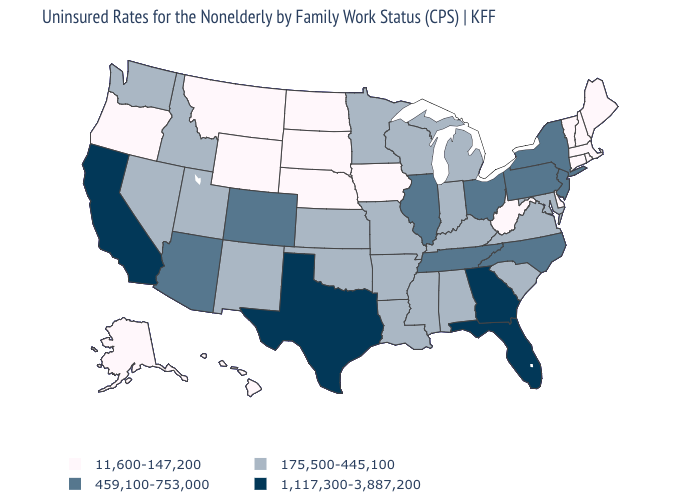What is the value of Tennessee?
Give a very brief answer. 459,100-753,000. Name the states that have a value in the range 1,117,300-3,887,200?
Short answer required. California, Florida, Georgia, Texas. Does Ohio have a lower value than Texas?
Keep it brief. Yes. Name the states that have a value in the range 11,600-147,200?
Give a very brief answer. Alaska, Connecticut, Delaware, Hawaii, Iowa, Maine, Massachusetts, Montana, Nebraska, New Hampshire, North Dakota, Oregon, Rhode Island, South Dakota, Vermont, West Virginia, Wyoming. What is the value of California?
Write a very short answer. 1,117,300-3,887,200. Does South Dakota have the highest value in the USA?
Give a very brief answer. No. Does Utah have a lower value than Minnesota?
Short answer required. No. Which states have the lowest value in the USA?
Answer briefly. Alaska, Connecticut, Delaware, Hawaii, Iowa, Maine, Massachusetts, Montana, Nebraska, New Hampshire, North Dakota, Oregon, Rhode Island, South Dakota, Vermont, West Virginia, Wyoming. What is the value of Minnesota?
Write a very short answer. 175,500-445,100. Name the states that have a value in the range 1,117,300-3,887,200?
Quick response, please. California, Florida, Georgia, Texas. Name the states that have a value in the range 11,600-147,200?
Short answer required. Alaska, Connecticut, Delaware, Hawaii, Iowa, Maine, Massachusetts, Montana, Nebraska, New Hampshire, North Dakota, Oregon, Rhode Island, South Dakota, Vermont, West Virginia, Wyoming. Name the states that have a value in the range 1,117,300-3,887,200?
Give a very brief answer. California, Florida, Georgia, Texas. What is the value of North Dakota?
Concise answer only. 11,600-147,200. Does Iowa have the same value as Nebraska?
Give a very brief answer. Yes. Does Alabama have the same value as Wyoming?
Concise answer only. No. 